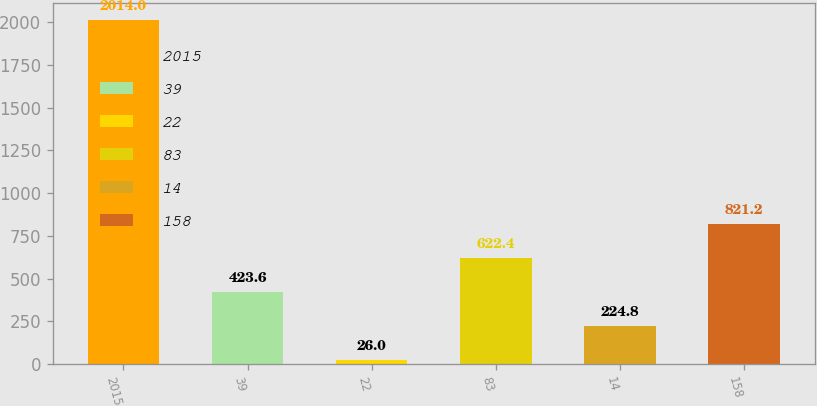Convert chart to OTSL. <chart><loc_0><loc_0><loc_500><loc_500><bar_chart><fcel>2015<fcel>39<fcel>22<fcel>83<fcel>14<fcel>158<nl><fcel>2014<fcel>423.6<fcel>26<fcel>622.4<fcel>224.8<fcel>821.2<nl></chart> 